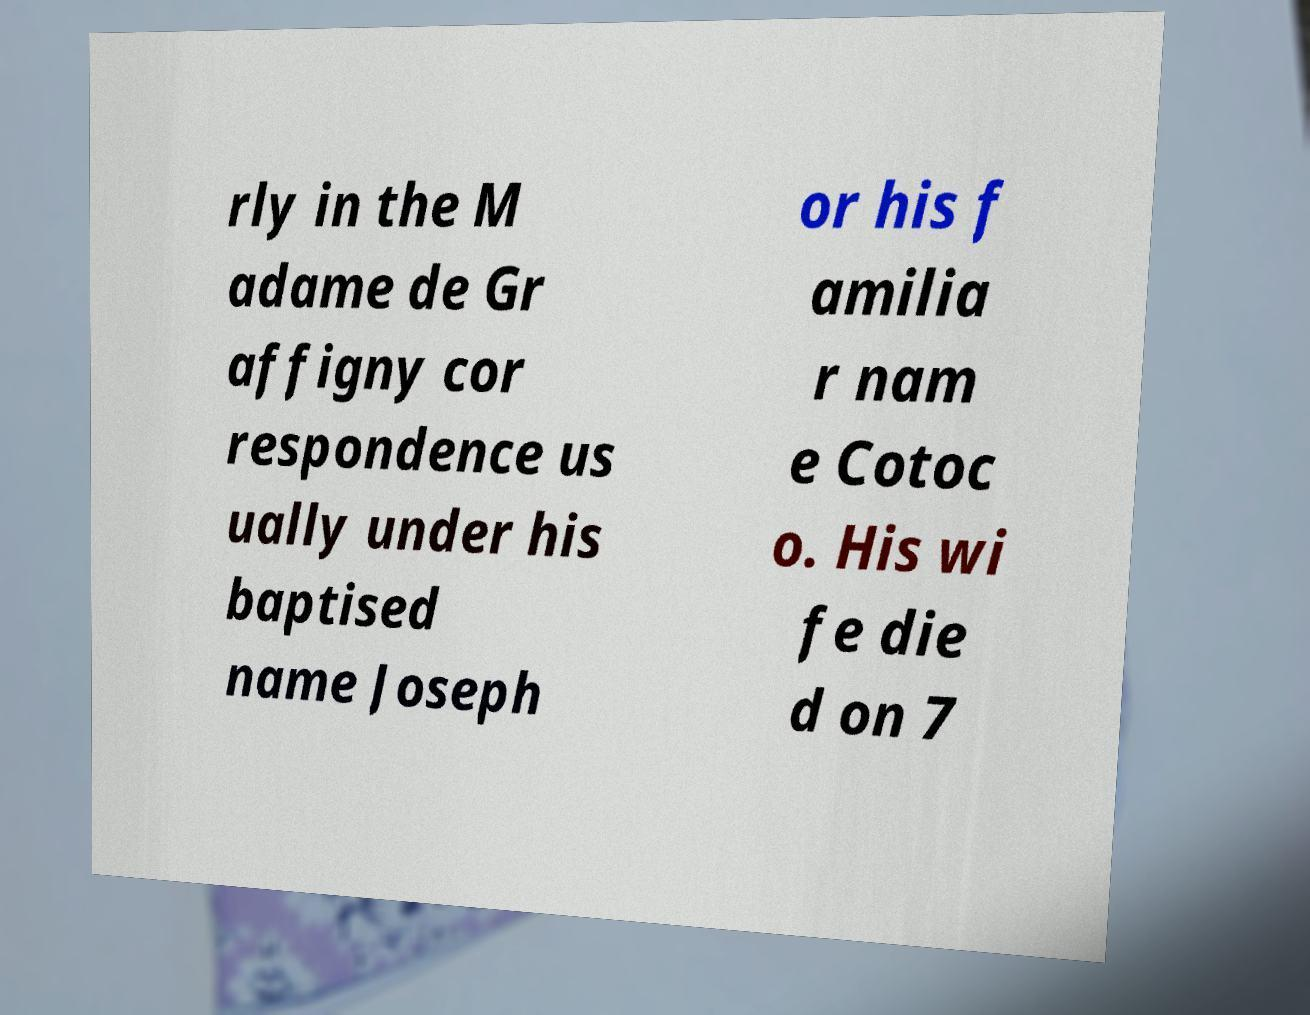There's text embedded in this image that I need extracted. Can you transcribe it verbatim? rly in the M adame de Gr affigny cor respondence us ually under his baptised name Joseph or his f amilia r nam e Cotoc o. His wi fe die d on 7 